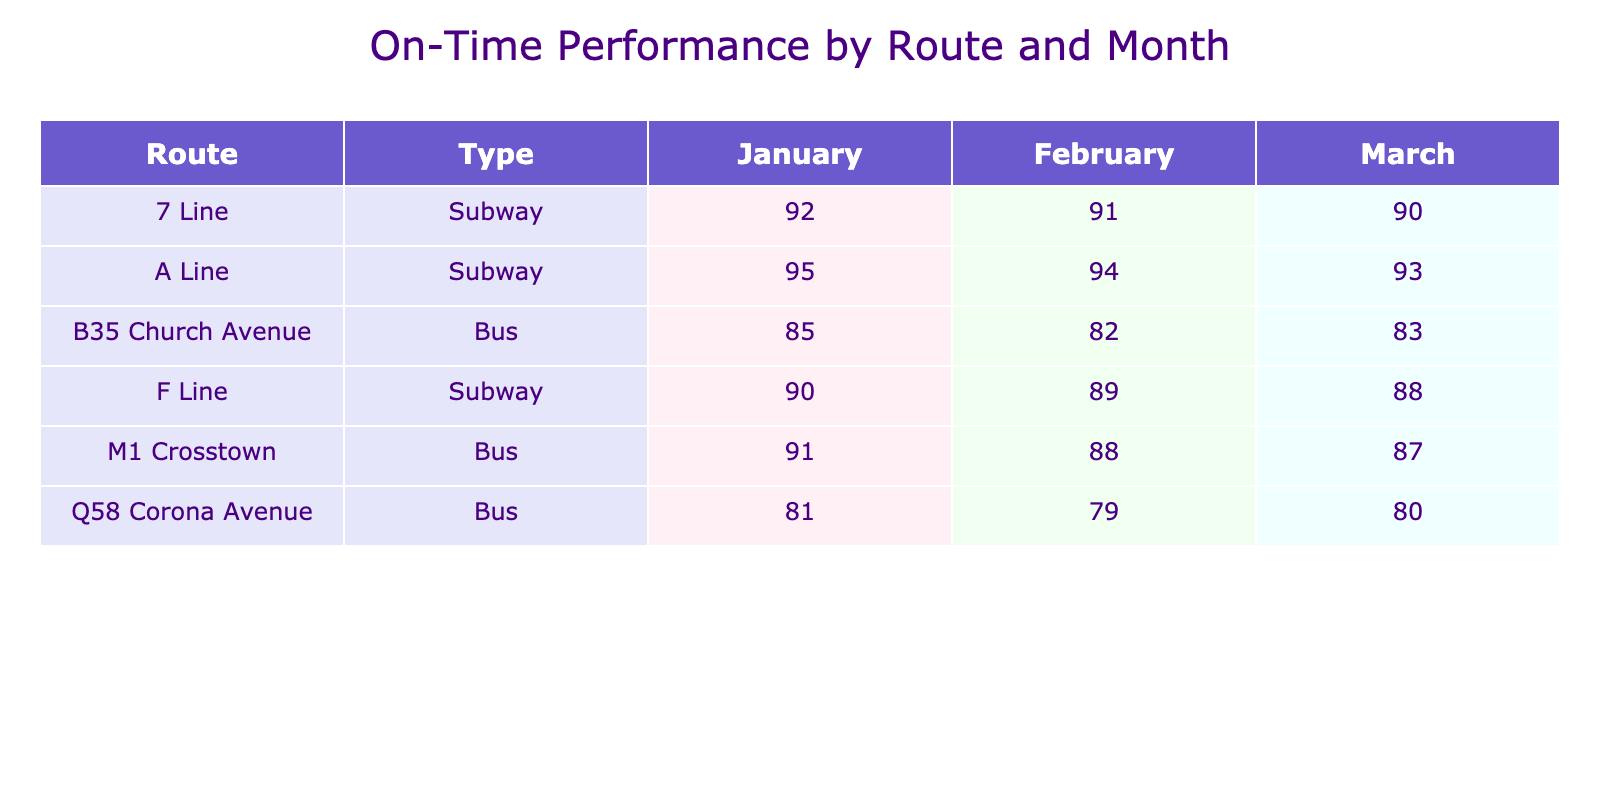What is the on-time percentage for the A Line in February? The table shows the on-time performance data for each route and month. For the A Line, the on-time percentage in February is listed directly in the relevant row.
Answer: 95 Which bus route had the highest on-time percentage in January? To find this, we look at all the bus routes in January and compare their on-time percentages. The M1 Crosstown has an on-time percentage of 88, the B35 Church Avenue has 82, and the Q58 Corona Avenue has 79. The M1 Crosstown has the highest value.
Answer: M1 Crosstown What was the total number of trips for the 7 Line across all three months? The table displays the total trips for each month and specific routes. For the 7 Line, the total trips are 5000 in January, 4700 in February, and 4900 in March. We sum these: 5000 + 4700 + 4900 = 14600.
Answer: 14600 What is the average on-time percentage for the B35 Church Avenue over the three months? The on-time percentages for the B35 Church Avenue in January, February, and March are 82, 85, and 83 respectively. We calculate the average by summing these values: 82 + 85 + 83 = 250, and then dividing by the number of months: 250 / 3 ≈ 83.33.
Answer: 83.33 Is the on-time performance for the F Line better in March than in February? Checking the on-time percentages for the F Line: in February it's 90, and in March it's 88. Since 90 is greater than 88, the performance in February is better.
Answer: No Which line had the most delays in January? The delays in January were as follows: M1 Crosstown had 1250 minutes, B35 Church Avenue had 1680 minutes, Q58 Corona Avenue had 2100 minutes, A Line had 720 minutes, 7 Line had 1150 minutes, and F Line had 1440 minutes. The Q58 Corona Avenue had the most delays at 2100 minutes.
Answer: Q58 Corona Avenue Which route had a consistent on-time percentage of 90 or above throughout the three months? We check the on-time percentages for each route across months. Only the A Line has percentages of 94, 95, and 93, which are all above 90. Therefore, it is the only route that consistently maintained this level.
Answer: A Line What is the difference in on-time percentage between the M1 Crosstown in January and March? The on-time percentages for the M1 Crosstown are 88 in January and 87 in March. The difference is calculated as 88 - 87 = 1.
Answer: 1 Which route had the highest ridership in February? Checking the ridership for February, M1 Crosstown had 87000, B35 Church Avenue had 78000, Q58 Corona Avenue had 84000, A Line had 294000, 7 Line had 329000, and F Line had 315000. The A Line had the highest ridership at 294000.
Answer: A Line 